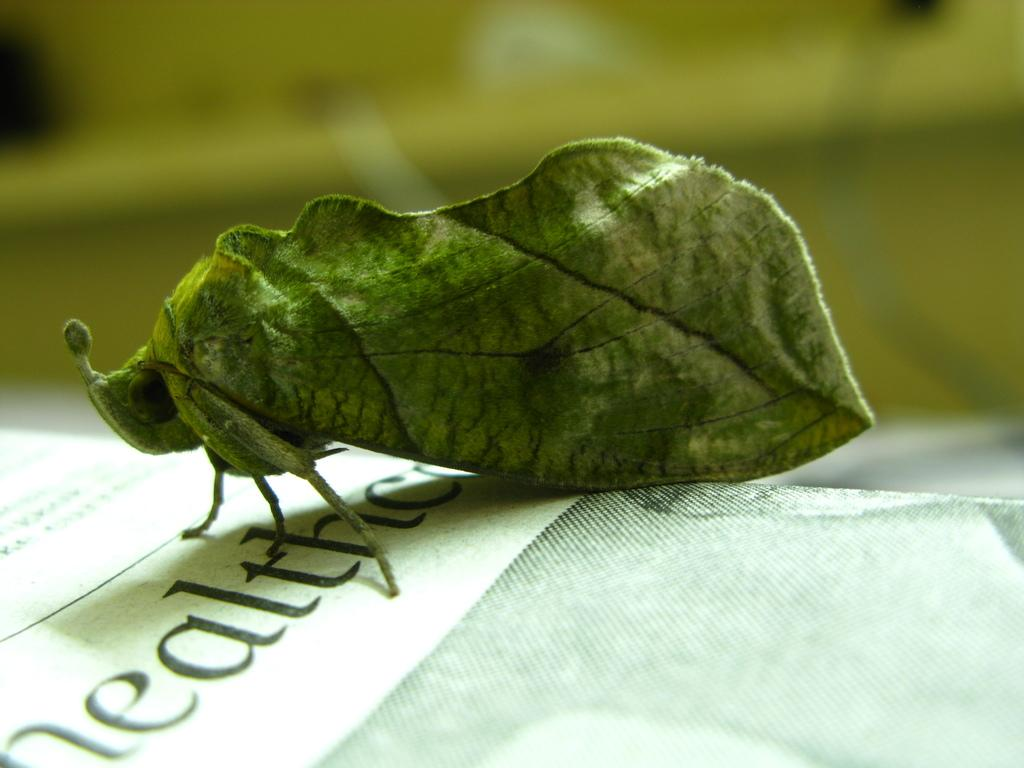What type of creature can be seen in the image? There is an insect in the image. What is located at the bottom of the image? There is a poster at the bottom of the image. What channel is the insect watching on the television in the image? There is no television present in the image, and therefore no channel can be observed. What type of apparel is the insect wearing in the image? Insects do not wear apparel, and there is no clothing visible in the image. 